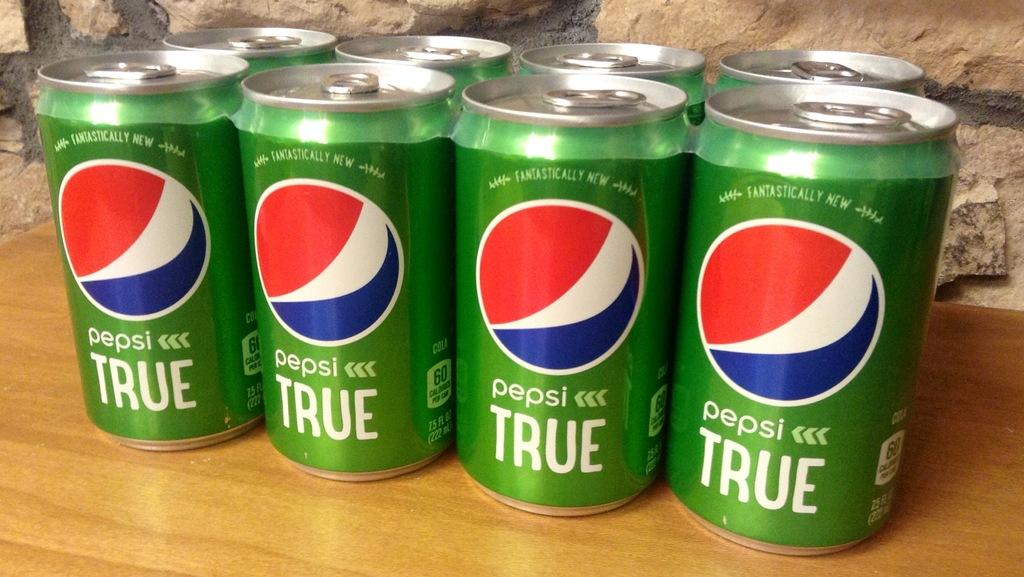<image>
Render a clear and concise summary of the photo. Eight green cans of Pepsi True are grouped together on a table. 